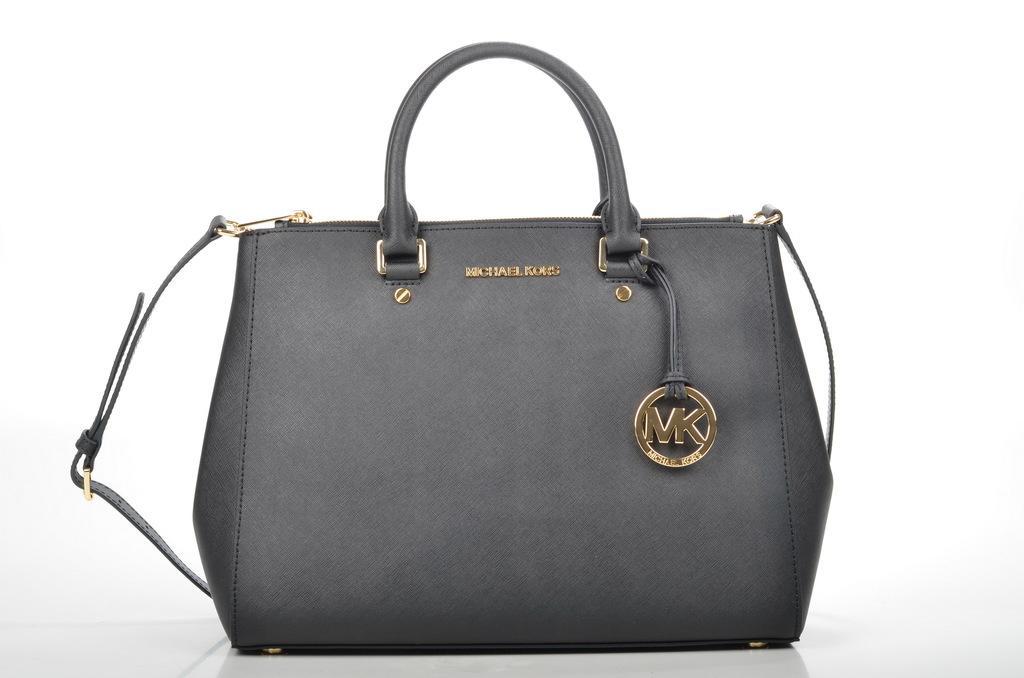Can you describe this image briefly? In this image a black color handbag is kept on the floor. The background is white in color. This image is taken inside a room. 